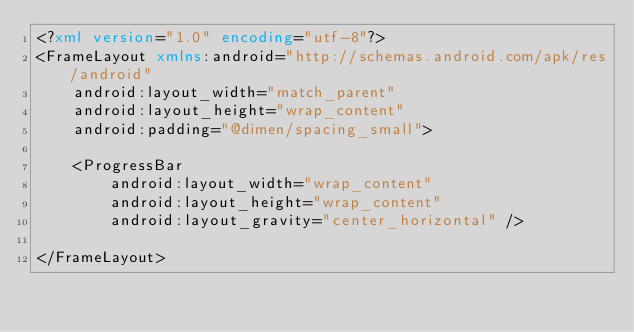Convert code to text. <code><loc_0><loc_0><loc_500><loc_500><_XML_><?xml version="1.0" encoding="utf-8"?>
<FrameLayout xmlns:android="http://schemas.android.com/apk/res/android"
    android:layout_width="match_parent"
    android:layout_height="wrap_content"
    android:padding="@dimen/spacing_small">

    <ProgressBar
        android:layout_width="wrap_content"
        android:layout_height="wrap_content"
        android:layout_gravity="center_horizontal" />

</FrameLayout></code> 